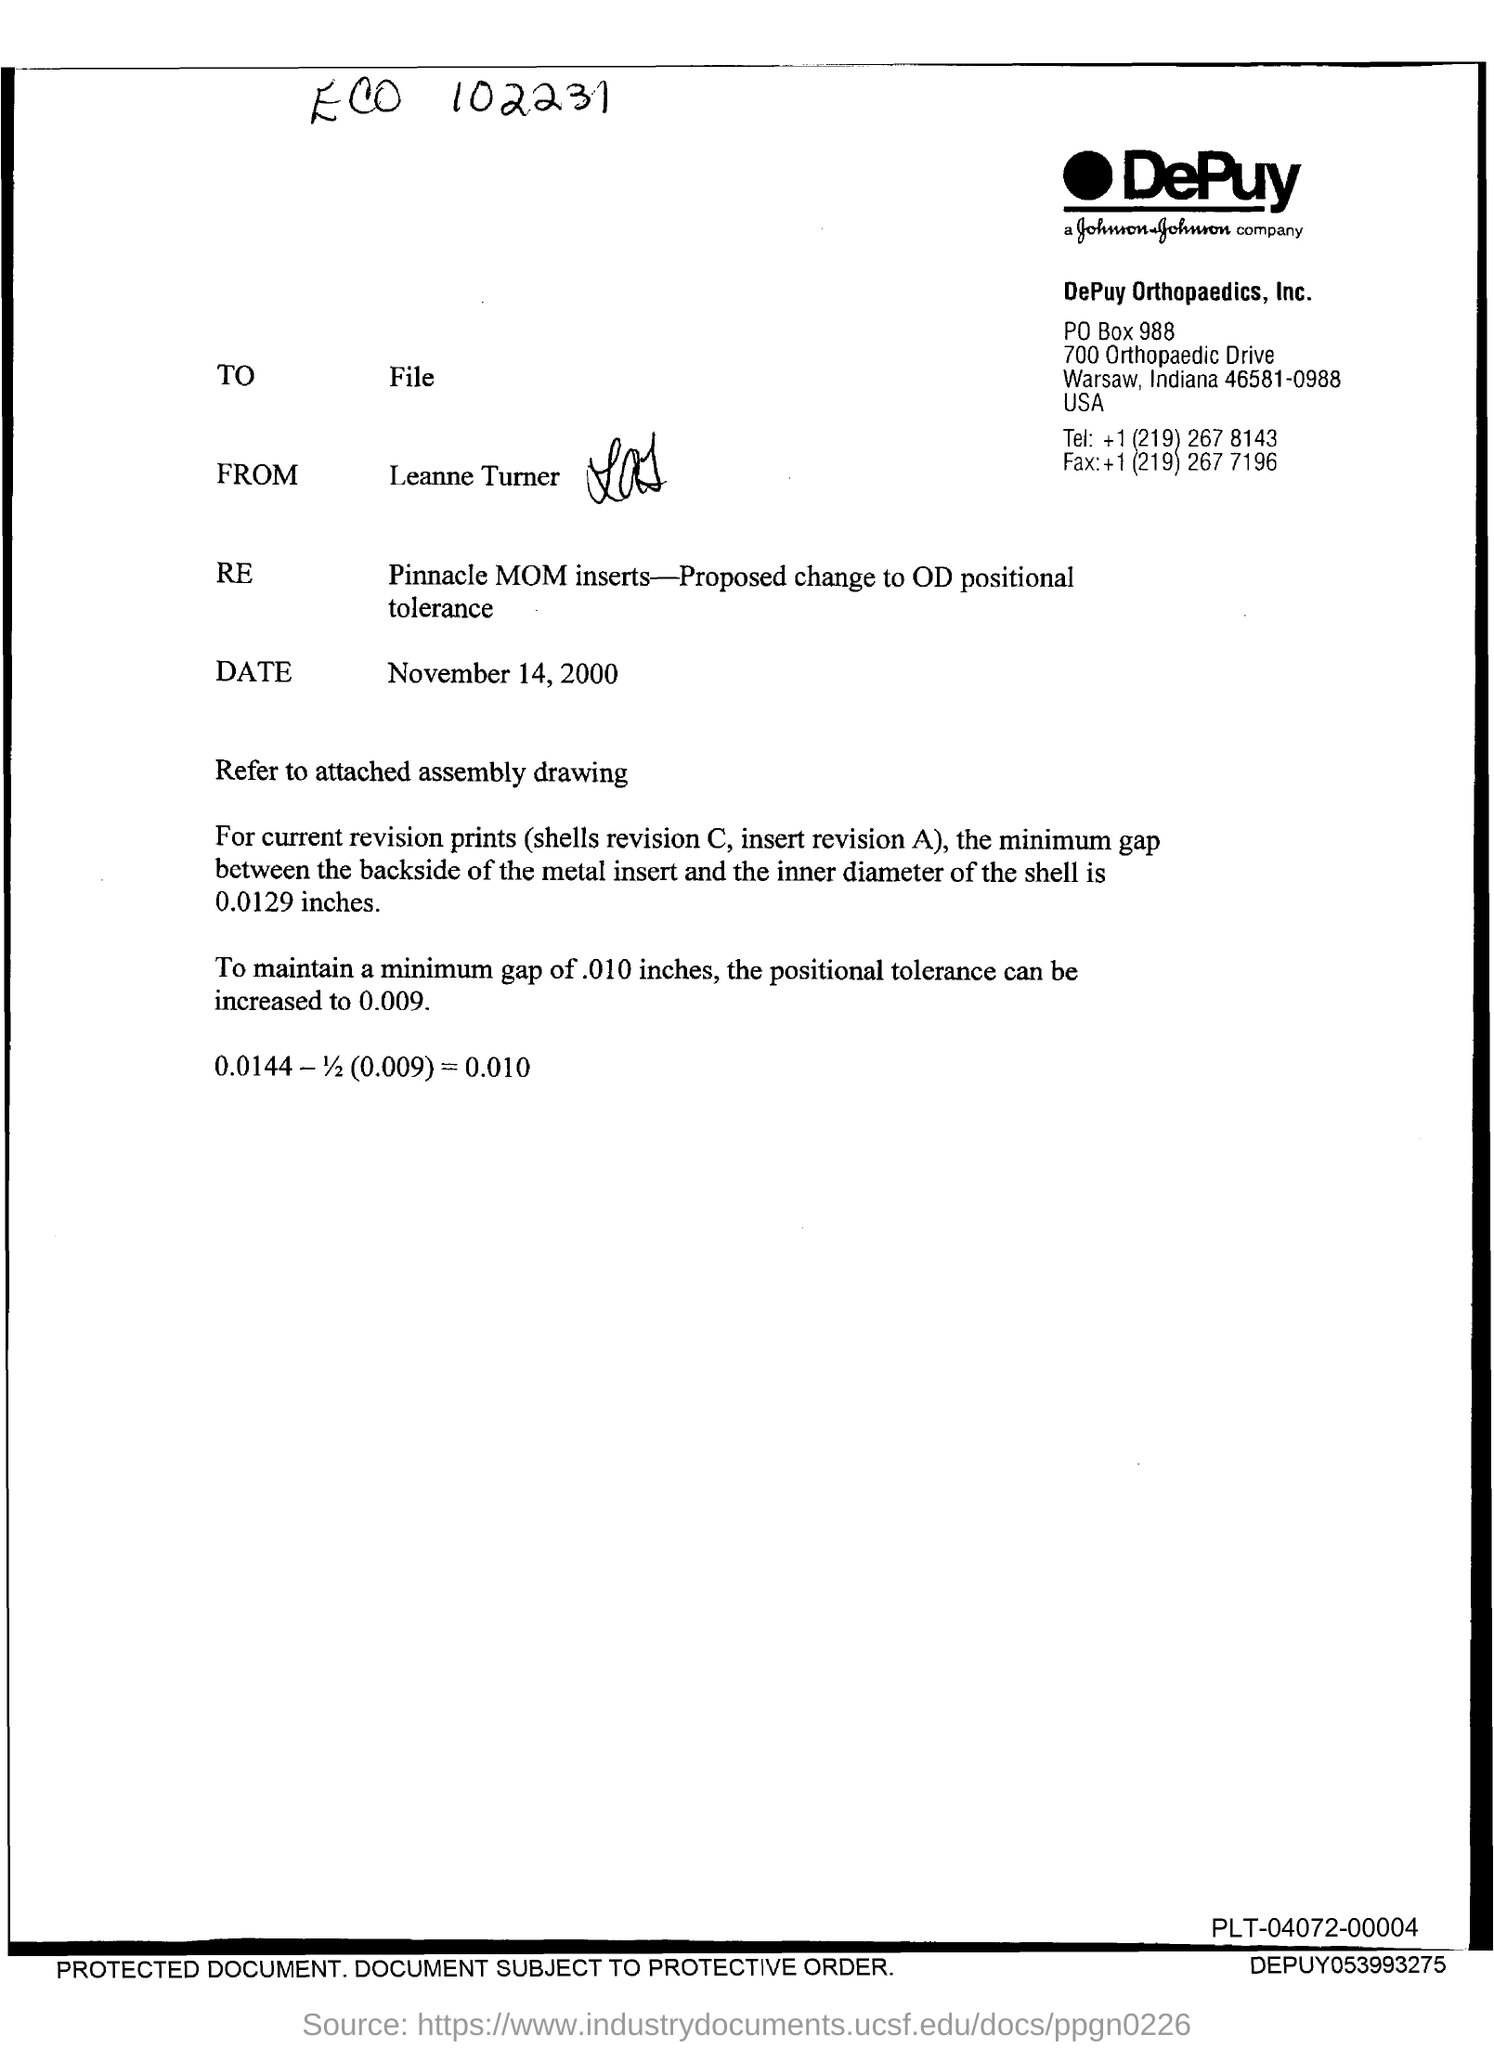Mention a couple of crucial points in this snapshot. The letter is from Leanne Turner. The fax number provided is +1 (219) 267 7196. The date mentioned in this letter is November 14, 2000. 